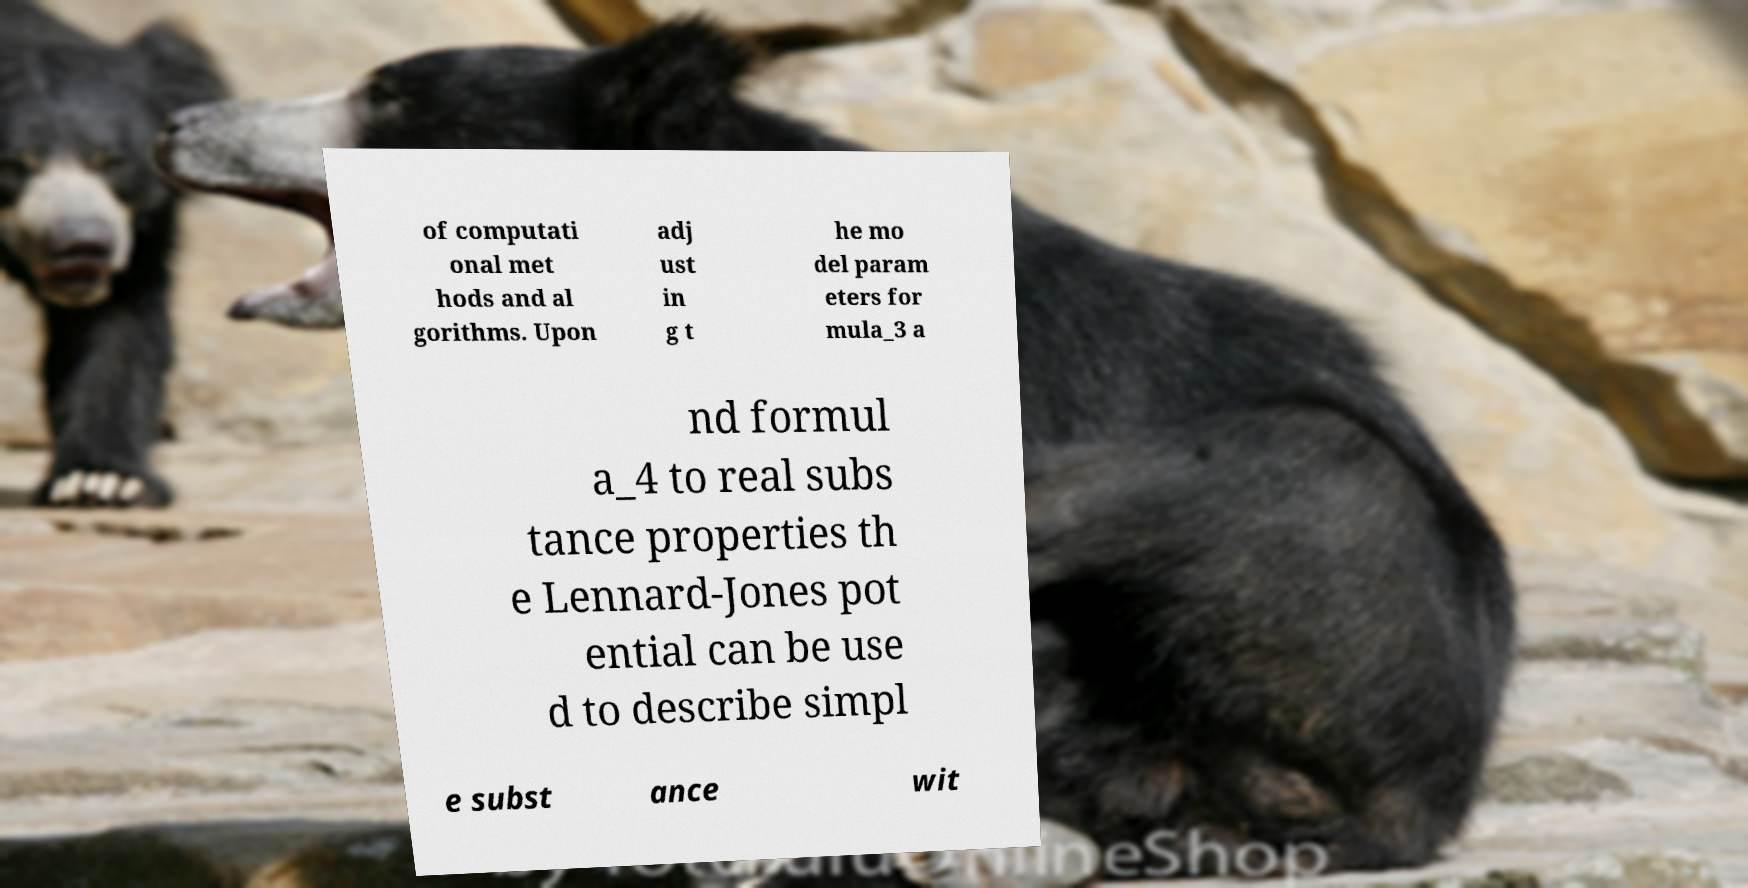Please read and relay the text visible in this image. What does it say? of computati onal met hods and al gorithms. Upon adj ust in g t he mo del param eters for mula_3 a nd formul a_4 to real subs tance properties th e Lennard-Jones pot ential can be use d to describe simpl e subst ance wit 